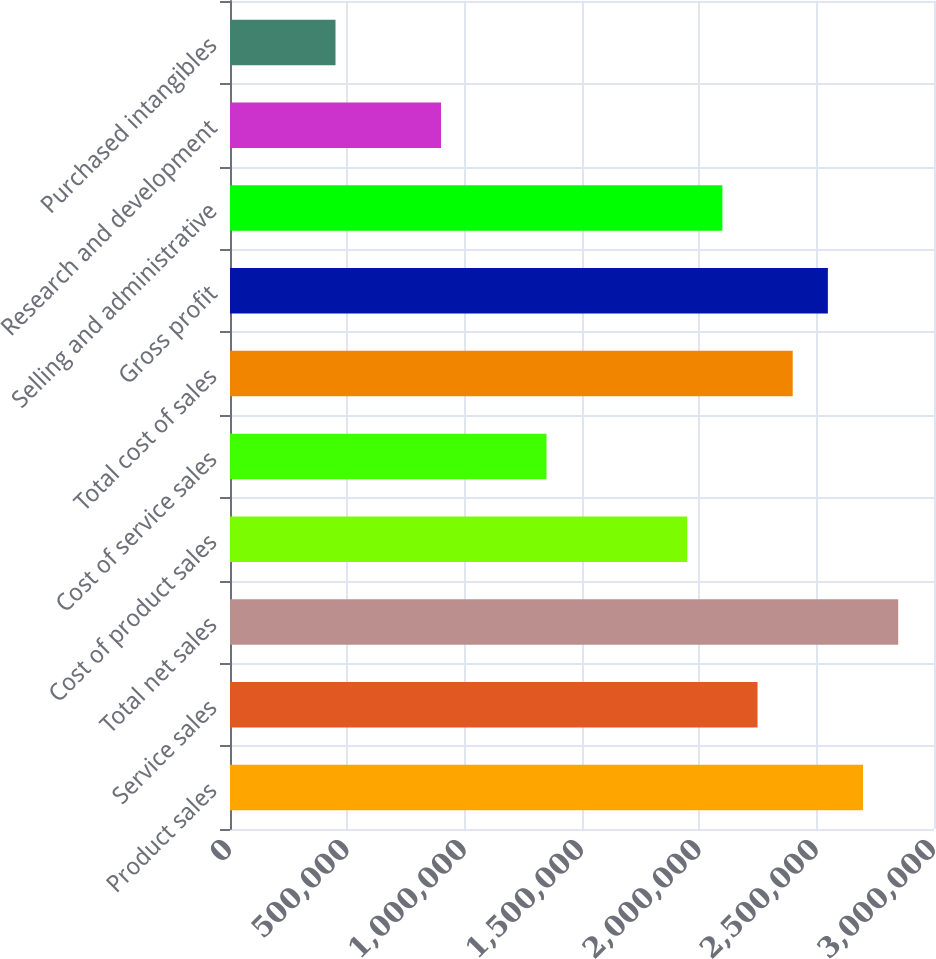Convert chart. <chart><loc_0><loc_0><loc_500><loc_500><bar_chart><fcel>Product sales<fcel>Service sales<fcel>Total net sales<fcel>Cost of product sales<fcel>Cost of service sales<fcel>Total cost of sales<fcel>Gross profit<fcel>Selling and administrative<fcel>Research and development<fcel>Purchased intangibles<nl><fcel>2.69766e+06<fcel>2.24805e+06<fcel>2.84753e+06<fcel>1.94831e+06<fcel>1.34883e+06<fcel>2.39792e+06<fcel>2.54779e+06<fcel>2.09818e+06<fcel>899221<fcel>449612<nl></chart> 